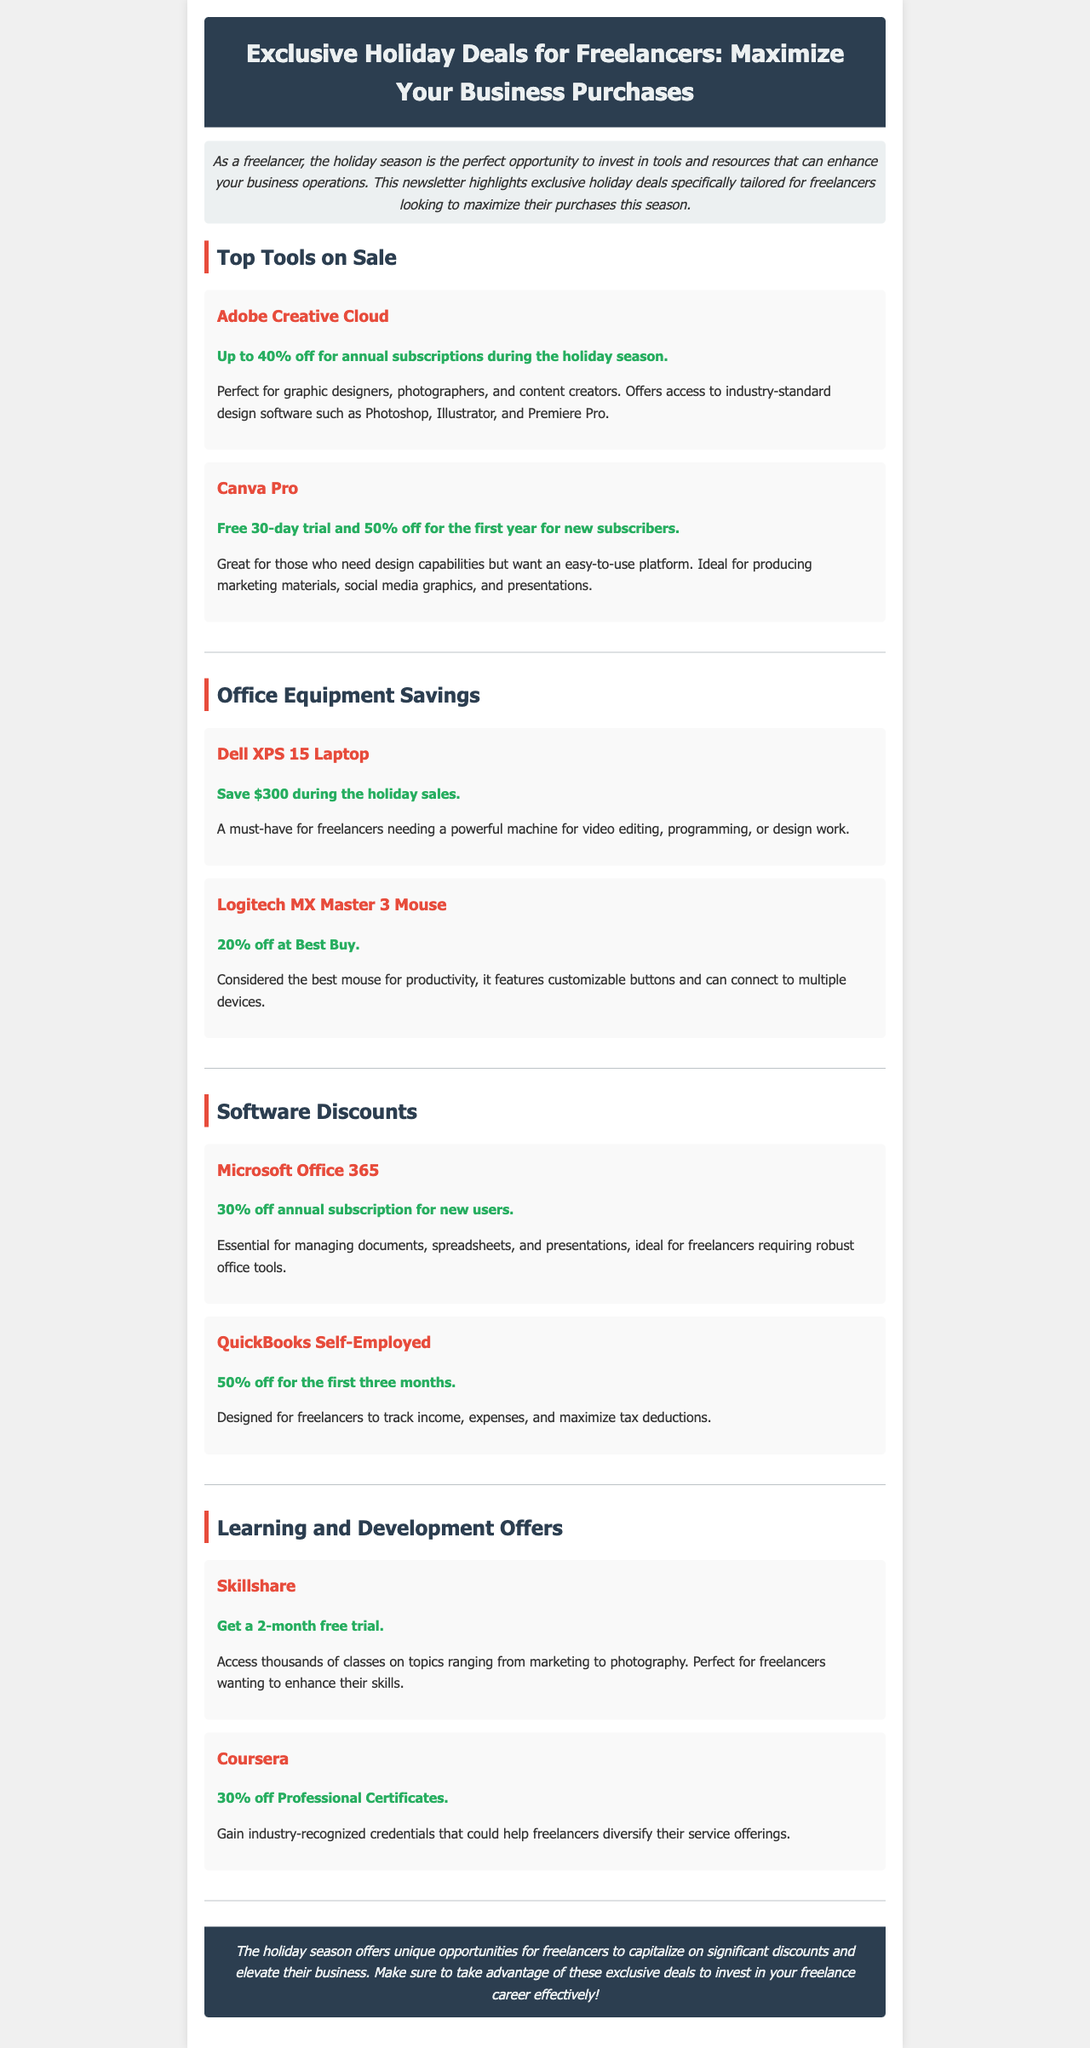What discount is offered for Adobe Creative Cloud subscriptions? The document states that Adobe Creative Cloud offers up to 40% off for annual subscriptions during the holiday season.
Answer: 40% off What is the main purpose of the newsletter? The introduction explains that the newsletter highlights exclusive holiday deals specifically tailored for freelancers looking to maximize their purchases this season.
Answer: Maximize their business purchases How much can you save on the Dell XPS 15 Laptop? The deal section mentions that you can save $300 during the holiday sales on the Dell XPS 15 Laptop.
Answer: $300 What is the duration of the free trial for Skillshare? The document states that Skillshare offers a 2-month free trial.
Answer: 2 months What percentage off is offered on QuickBooks Self-Employed for the first three months? The document mentions that QuickBooks Self-Employed offers 50% off for the first three months.
Answer: 50% Which device has a 20% discount available at Best Buy? The document specifically mentions that the Logitech MX Master 3 Mouse has a 20% off promotion at Best Buy.
Answer: Logitech MX Master 3 Mouse 